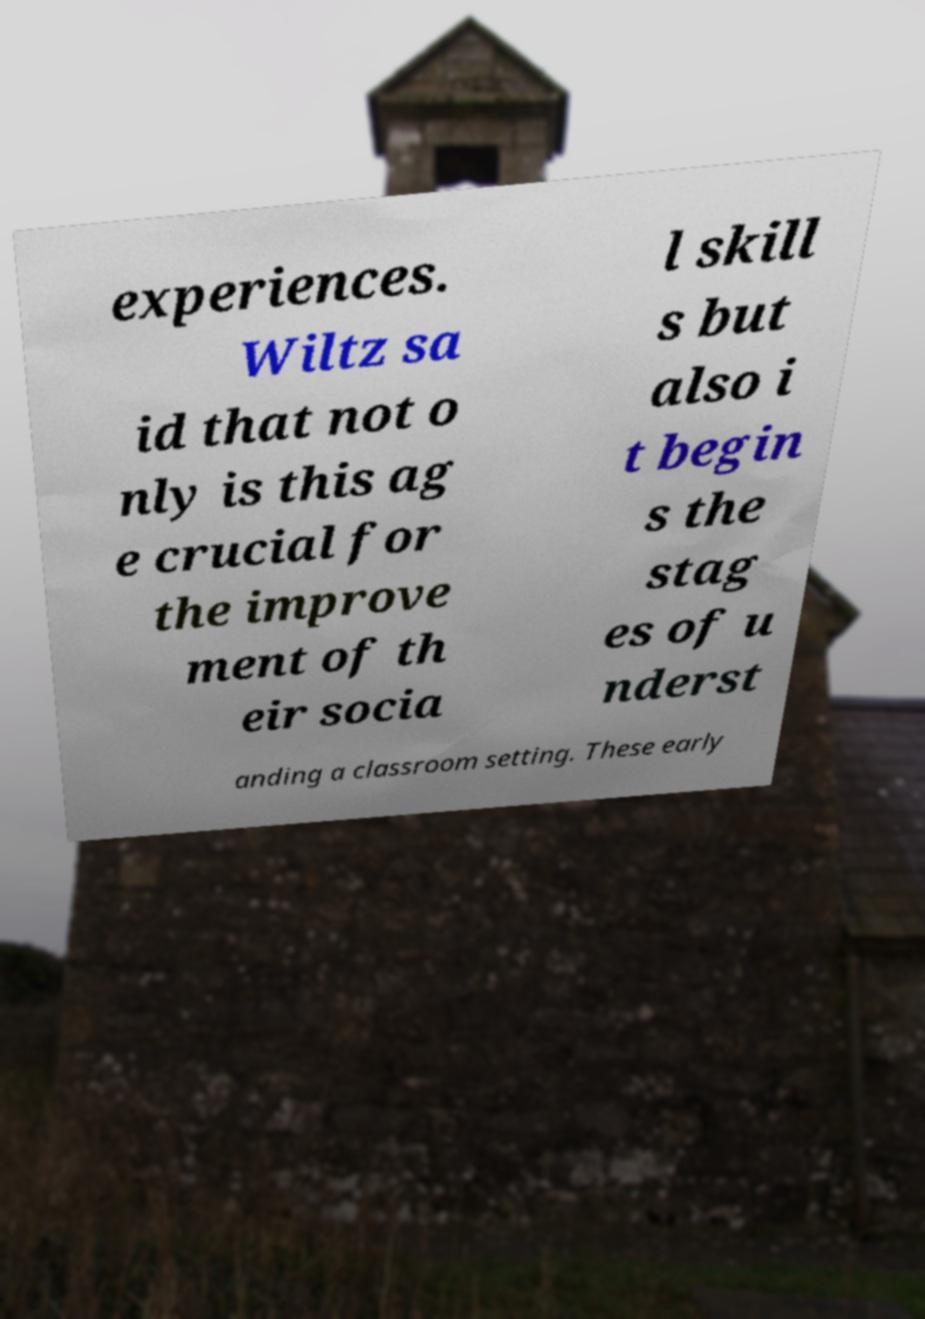Please read and relay the text visible in this image. What does it say? experiences. Wiltz sa id that not o nly is this ag e crucial for the improve ment of th eir socia l skill s but also i t begin s the stag es of u nderst anding a classroom setting. These early 